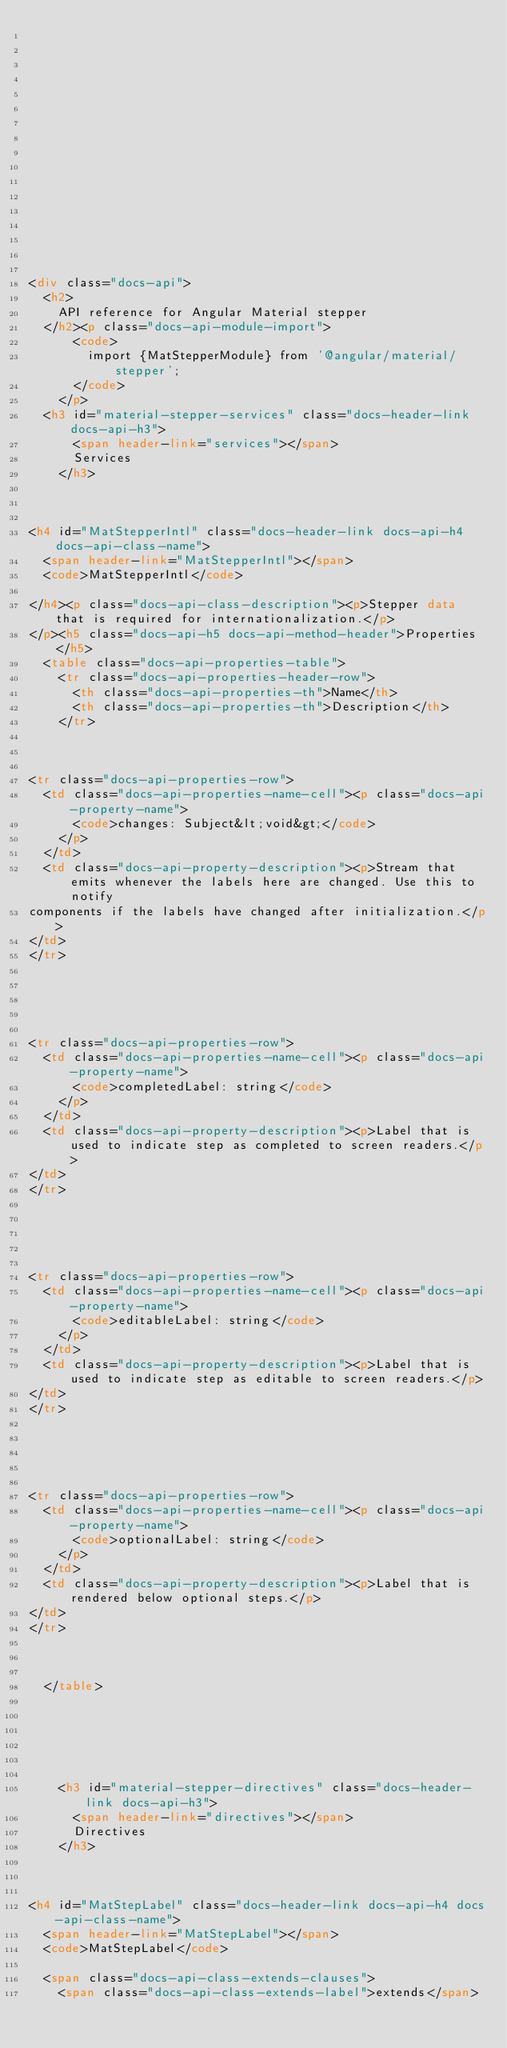Convert code to text. <code><loc_0><loc_0><loc_500><loc_500><_HTML_>
















<div class="docs-api">
  <h2>
    API reference for Angular Material stepper
  </h2><p class="docs-api-module-import">
      <code>
        import {MatStepperModule} from '@angular/material/stepper';
      </code>
    </p>
  <h3 id="material-stepper-services" class="docs-header-link docs-api-h3">
      <span header-link="services"></span>
      Services
    </h3>
    
      

<h4 id="MatStepperIntl" class="docs-header-link docs-api-h4 docs-api-class-name">
  <span header-link="MatStepperIntl"></span>
  <code>MatStepperIntl</code>
  
</h4><p class="docs-api-class-description"><p>Stepper data that is required for internationalization.</p>
</p><h5 class="docs-api-h5 docs-api-method-header">Properties</h5>
  <table class="docs-api-properties-table">
    <tr class="docs-api-properties-header-row">
      <th class="docs-api-properties-th">Name</th>
      <th class="docs-api-properties-th">Description</th>
    </tr>
    
      

<tr class="docs-api-properties-row">
  <td class="docs-api-properties-name-cell"><p class="docs-api-property-name">
      <code>changes: Subject&lt;void&gt;</code>
    </p>
  </td>
  <td class="docs-api-property-description"><p>Stream that emits whenever the labels here are changed. Use this to notify
components if the labels have changed after initialization.</p>
</td>
</tr>


    
      

<tr class="docs-api-properties-row">
  <td class="docs-api-properties-name-cell"><p class="docs-api-property-name">
      <code>completedLabel: string</code>
    </p>
  </td>
  <td class="docs-api-property-description"><p>Label that is used to indicate step as completed to screen readers.</p>
</td>
</tr>


    
      

<tr class="docs-api-properties-row">
  <td class="docs-api-properties-name-cell"><p class="docs-api-property-name">
      <code>editableLabel: string</code>
    </p>
  </td>
  <td class="docs-api-property-description"><p>Label that is used to indicate step as editable to screen readers.</p>
</td>
</tr>


    
      

<tr class="docs-api-properties-row">
  <td class="docs-api-properties-name-cell"><p class="docs-api-property-name">
      <code>optionalLabel: string</code>
    </p>
  </td>
  <td class="docs-api-property-description"><p>Label that is rendered below optional steps.</p>
</td>
</tr>


    
  </table>






    <h3 id="material-stepper-directives" class="docs-header-link docs-api-h3">
      <span header-link="directives"></span>
      Directives
    </h3>
    
      

<h4 id="MatStepLabel" class="docs-header-link docs-api-h4 docs-api-class-name">
  <span header-link="MatStepLabel"></span>
  <code>MatStepLabel</code>
  
  <span class="docs-api-class-extends-clauses">
    <span class="docs-api-class-extends-label">extends</span></code> 